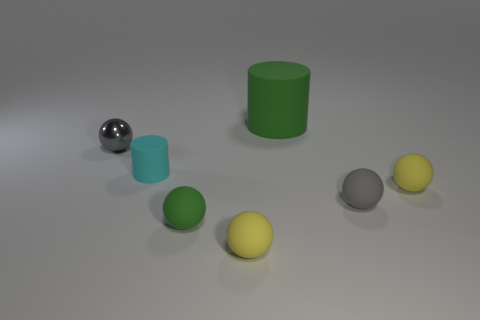Subtract all tiny gray balls. How many balls are left? 3 Subtract all yellow spheres. How many spheres are left? 3 Add 1 tiny rubber cylinders. How many objects exist? 8 Subtract all balls. How many objects are left? 2 Subtract 1 cylinders. How many cylinders are left? 1 Subtract all blue balls. Subtract all gray cylinders. How many balls are left? 5 Subtract all red cylinders. How many gray spheres are left? 2 Subtract all spheres. Subtract all yellow matte spheres. How many objects are left? 0 Add 3 large green rubber cylinders. How many large green rubber cylinders are left? 4 Add 7 cyan matte objects. How many cyan matte objects exist? 8 